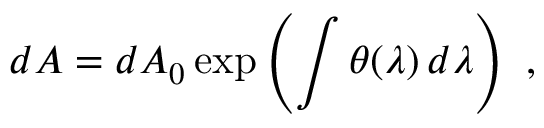Convert formula to latex. <formula><loc_0><loc_0><loc_500><loc_500>d A = d A _ { 0 } \exp \left ( \int \theta ( \lambda ) \, d \lambda \right ) \ ,</formula> 